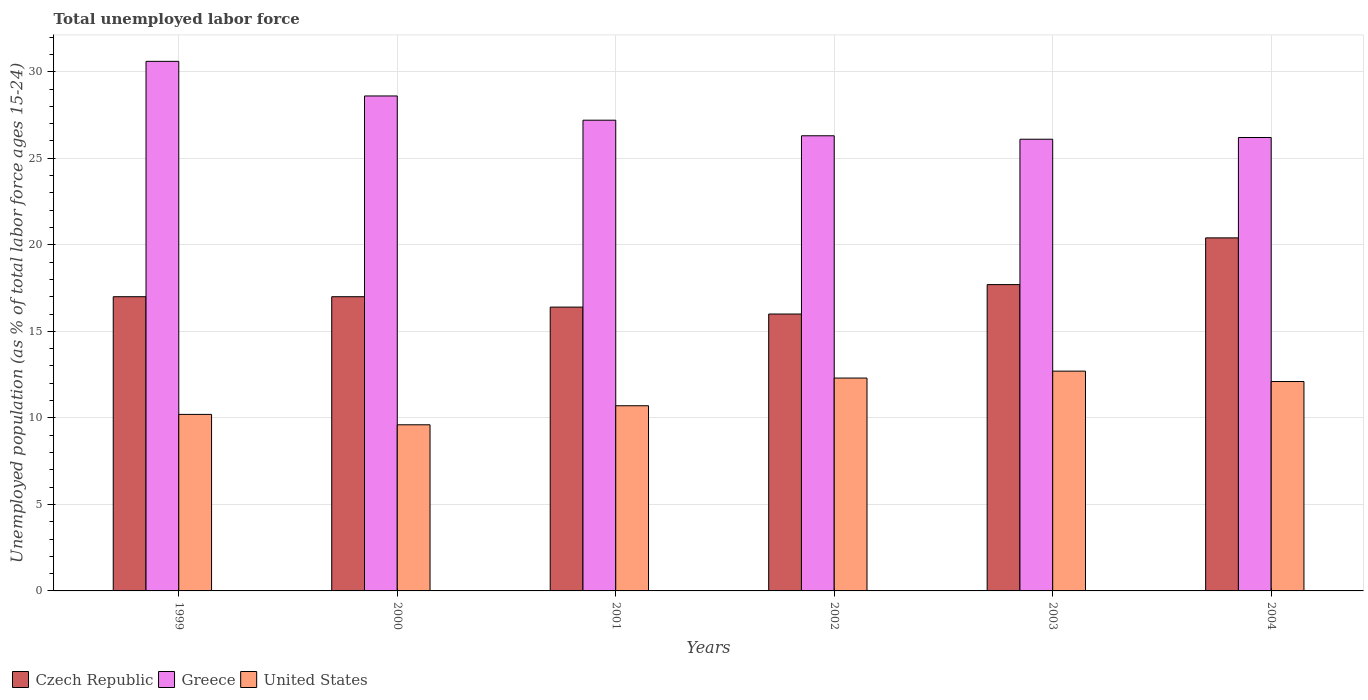How many groups of bars are there?
Your response must be concise. 6. How many bars are there on the 1st tick from the right?
Offer a very short reply. 3. What is the percentage of unemployed population in in United States in 2001?
Offer a very short reply. 10.7. Across all years, what is the maximum percentage of unemployed population in in United States?
Ensure brevity in your answer.  12.7. Across all years, what is the minimum percentage of unemployed population in in United States?
Offer a very short reply. 9.6. What is the total percentage of unemployed population in in Greece in the graph?
Provide a short and direct response. 165. What is the difference between the percentage of unemployed population in in Czech Republic in 2002 and that in 2004?
Your answer should be very brief. -4.4. What is the difference between the percentage of unemployed population in in United States in 2000 and the percentage of unemployed population in in Czech Republic in 2001?
Offer a terse response. -6.8. What is the average percentage of unemployed population in in United States per year?
Provide a succinct answer. 11.27. In the year 2000, what is the difference between the percentage of unemployed population in in Czech Republic and percentage of unemployed population in in Greece?
Your answer should be very brief. -11.6. In how many years, is the percentage of unemployed population in in Greece greater than 25 %?
Keep it short and to the point. 6. What is the ratio of the percentage of unemployed population in in Czech Republic in 2001 to that in 2002?
Your answer should be compact. 1.02. What is the difference between the highest and the second highest percentage of unemployed population in in Czech Republic?
Provide a short and direct response. 2.7. What does the 1st bar from the left in 2000 represents?
Your answer should be very brief. Czech Republic. Is it the case that in every year, the sum of the percentage of unemployed population in in United States and percentage of unemployed population in in Czech Republic is greater than the percentage of unemployed population in in Greece?
Provide a succinct answer. No. Are all the bars in the graph horizontal?
Ensure brevity in your answer.  No. How many years are there in the graph?
Ensure brevity in your answer.  6. What is the difference between two consecutive major ticks on the Y-axis?
Offer a very short reply. 5. Does the graph contain any zero values?
Offer a terse response. No. Where does the legend appear in the graph?
Make the answer very short. Bottom left. What is the title of the graph?
Offer a terse response. Total unemployed labor force. Does "Samoa" appear as one of the legend labels in the graph?
Provide a short and direct response. No. What is the label or title of the Y-axis?
Your answer should be compact. Unemployed population (as % of total labor force ages 15-24). What is the Unemployed population (as % of total labor force ages 15-24) of Greece in 1999?
Your answer should be compact. 30.6. What is the Unemployed population (as % of total labor force ages 15-24) of United States in 1999?
Ensure brevity in your answer.  10.2. What is the Unemployed population (as % of total labor force ages 15-24) in Czech Republic in 2000?
Your answer should be very brief. 17. What is the Unemployed population (as % of total labor force ages 15-24) of Greece in 2000?
Ensure brevity in your answer.  28.6. What is the Unemployed population (as % of total labor force ages 15-24) of United States in 2000?
Offer a very short reply. 9.6. What is the Unemployed population (as % of total labor force ages 15-24) of Czech Republic in 2001?
Ensure brevity in your answer.  16.4. What is the Unemployed population (as % of total labor force ages 15-24) in Greece in 2001?
Provide a short and direct response. 27.2. What is the Unemployed population (as % of total labor force ages 15-24) in United States in 2001?
Your response must be concise. 10.7. What is the Unemployed population (as % of total labor force ages 15-24) of Czech Republic in 2002?
Provide a succinct answer. 16. What is the Unemployed population (as % of total labor force ages 15-24) in Greece in 2002?
Make the answer very short. 26.3. What is the Unemployed population (as % of total labor force ages 15-24) of United States in 2002?
Provide a succinct answer. 12.3. What is the Unemployed population (as % of total labor force ages 15-24) in Czech Republic in 2003?
Your answer should be compact. 17.7. What is the Unemployed population (as % of total labor force ages 15-24) in Greece in 2003?
Your response must be concise. 26.1. What is the Unemployed population (as % of total labor force ages 15-24) of United States in 2003?
Provide a short and direct response. 12.7. What is the Unemployed population (as % of total labor force ages 15-24) in Czech Republic in 2004?
Provide a short and direct response. 20.4. What is the Unemployed population (as % of total labor force ages 15-24) of Greece in 2004?
Offer a very short reply. 26.2. What is the Unemployed population (as % of total labor force ages 15-24) of United States in 2004?
Make the answer very short. 12.1. Across all years, what is the maximum Unemployed population (as % of total labor force ages 15-24) in Czech Republic?
Keep it short and to the point. 20.4. Across all years, what is the maximum Unemployed population (as % of total labor force ages 15-24) of Greece?
Provide a succinct answer. 30.6. Across all years, what is the maximum Unemployed population (as % of total labor force ages 15-24) of United States?
Make the answer very short. 12.7. Across all years, what is the minimum Unemployed population (as % of total labor force ages 15-24) in Greece?
Give a very brief answer. 26.1. Across all years, what is the minimum Unemployed population (as % of total labor force ages 15-24) in United States?
Make the answer very short. 9.6. What is the total Unemployed population (as % of total labor force ages 15-24) of Czech Republic in the graph?
Provide a short and direct response. 104.5. What is the total Unemployed population (as % of total labor force ages 15-24) of Greece in the graph?
Ensure brevity in your answer.  165. What is the total Unemployed population (as % of total labor force ages 15-24) in United States in the graph?
Your response must be concise. 67.6. What is the difference between the Unemployed population (as % of total labor force ages 15-24) in Czech Republic in 1999 and that in 2000?
Offer a terse response. 0. What is the difference between the Unemployed population (as % of total labor force ages 15-24) of Czech Republic in 1999 and that in 2001?
Your response must be concise. 0.6. What is the difference between the Unemployed population (as % of total labor force ages 15-24) in Czech Republic in 1999 and that in 2002?
Keep it short and to the point. 1. What is the difference between the Unemployed population (as % of total labor force ages 15-24) of Greece in 1999 and that in 2002?
Your answer should be compact. 4.3. What is the difference between the Unemployed population (as % of total labor force ages 15-24) of Czech Republic in 1999 and that in 2003?
Make the answer very short. -0.7. What is the difference between the Unemployed population (as % of total labor force ages 15-24) of Greece in 1999 and that in 2003?
Your answer should be very brief. 4.5. What is the difference between the Unemployed population (as % of total labor force ages 15-24) in United States in 1999 and that in 2003?
Your response must be concise. -2.5. What is the difference between the Unemployed population (as % of total labor force ages 15-24) of Czech Republic in 1999 and that in 2004?
Your response must be concise. -3.4. What is the difference between the Unemployed population (as % of total labor force ages 15-24) in Czech Republic in 2000 and that in 2001?
Your response must be concise. 0.6. What is the difference between the Unemployed population (as % of total labor force ages 15-24) in Czech Republic in 2000 and that in 2002?
Offer a very short reply. 1. What is the difference between the Unemployed population (as % of total labor force ages 15-24) in Czech Republic in 2000 and that in 2003?
Your answer should be very brief. -0.7. What is the difference between the Unemployed population (as % of total labor force ages 15-24) of Greece in 2000 and that in 2004?
Make the answer very short. 2.4. What is the difference between the Unemployed population (as % of total labor force ages 15-24) in Czech Republic in 2001 and that in 2002?
Your answer should be very brief. 0.4. What is the difference between the Unemployed population (as % of total labor force ages 15-24) of Greece in 2001 and that in 2002?
Provide a short and direct response. 0.9. What is the difference between the Unemployed population (as % of total labor force ages 15-24) in United States in 2001 and that in 2002?
Provide a short and direct response. -1.6. What is the difference between the Unemployed population (as % of total labor force ages 15-24) of Czech Republic in 2001 and that in 2003?
Give a very brief answer. -1.3. What is the difference between the Unemployed population (as % of total labor force ages 15-24) in Greece in 2001 and that in 2003?
Make the answer very short. 1.1. What is the difference between the Unemployed population (as % of total labor force ages 15-24) in United States in 2001 and that in 2003?
Keep it short and to the point. -2. What is the difference between the Unemployed population (as % of total labor force ages 15-24) in Czech Republic in 2001 and that in 2004?
Your answer should be compact. -4. What is the difference between the Unemployed population (as % of total labor force ages 15-24) in Greece in 2001 and that in 2004?
Your answer should be compact. 1. What is the difference between the Unemployed population (as % of total labor force ages 15-24) of Czech Republic in 2002 and that in 2003?
Your answer should be compact. -1.7. What is the difference between the Unemployed population (as % of total labor force ages 15-24) in Greece in 2002 and that in 2003?
Provide a short and direct response. 0.2. What is the difference between the Unemployed population (as % of total labor force ages 15-24) in Greece in 2002 and that in 2004?
Give a very brief answer. 0.1. What is the difference between the Unemployed population (as % of total labor force ages 15-24) of United States in 2002 and that in 2004?
Keep it short and to the point. 0.2. What is the difference between the Unemployed population (as % of total labor force ages 15-24) of Czech Republic in 1999 and the Unemployed population (as % of total labor force ages 15-24) of Greece in 2001?
Give a very brief answer. -10.2. What is the difference between the Unemployed population (as % of total labor force ages 15-24) in Czech Republic in 1999 and the Unemployed population (as % of total labor force ages 15-24) in United States in 2001?
Your response must be concise. 6.3. What is the difference between the Unemployed population (as % of total labor force ages 15-24) of Greece in 1999 and the Unemployed population (as % of total labor force ages 15-24) of United States in 2001?
Your response must be concise. 19.9. What is the difference between the Unemployed population (as % of total labor force ages 15-24) in Czech Republic in 1999 and the Unemployed population (as % of total labor force ages 15-24) in Greece in 2002?
Offer a very short reply. -9.3. What is the difference between the Unemployed population (as % of total labor force ages 15-24) in Czech Republic in 1999 and the Unemployed population (as % of total labor force ages 15-24) in United States in 2002?
Provide a succinct answer. 4.7. What is the difference between the Unemployed population (as % of total labor force ages 15-24) of Greece in 1999 and the Unemployed population (as % of total labor force ages 15-24) of United States in 2003?
Give a very brief answer. 17.9. What is the difference between the Unemployed population (as % of total labor force ages 15-24) in Greece in 1999 and the Unemployed population (as % of total labor force ages 15-24) in United States in 2004?
Provide a succinct answer. 18.5. What is the difference between the Unemployed population (as % of total labor force ages 15-24) in Czech Republic in 2000 and the Unemployed population (as % of total labor force ages 15-24) in Greece in 2001?
Your answer should be very brief. -10.2. What is the difference between the Unemployed population (as % of total labor force ages 15-24) in Greece in 2000 and the Unemployed population (as % of total labor force ages 15-24) in United States in 2001?
Provide a succinct answer. 17.9. What is the difference between the Unemployed population (as % of total labor force ages 15-24) of Czech Republic in 2000 and the Unemployed population (as % of total labor force ages 15-24) of Greece in 2002?
Provide a succinct answer. -9.3. What is the difference between the Unemployed population (as % of total labor force ages 15-24) of Czech Republic in 2000 and the Unemployed population (as % of total labor force ages 15-24) of United States in 2002?
Keep it short and to the point. 4.7. What is the difference between the Unemployed population (as % of total labor force ages 15-24) in Czech Republic in 2000 and the Unemployed population (as % of total labor force ages 15-24) in Greece in 2003?
Keep it short and to the point. -9.1. What is the difference between the Unemployed population (as % of total labor force ages 15-24) of Czech Republic in 2000 and the Unemployed population (as % of total labor force ages 15-24) of United States in 2003?
Your response must be concise. 4.3. What is the difference between the Unemployed population (as % of total labor force ages 15-24) in Greece in 2000 and the Unemployed population (as % of total labor force ages 15-24) in United States in 2003?
Offer a terse response. 15.9. What is the difference between the Unemployed population (as % of total labor force ages 15-24) of Czech Republic in 2000 and the Unemployed population (as % of total labor force ages 15-24) of United States in 2004?
Your response must be concise. 4.9. What is the difference between the Unemployed population (as % of total labor force ages 15-24) of Czech Republic in 2001 and the Unemployed population (as % of total labor force ages 15-24) of Greece in 2002?
Ensure brevity in your answer.  -9.9. What is the difference between the Unemployed population (as % of total labor force ages 15-24) of Czech Republic in 2001 and the Unemployed population (as % of total labor force ages 15-24) of United States in 2002?
Your answer should be very brief. 4.1. What is the difference between the Unemployed population (as % of total labor force ages 15-24) of Greece in 2001 and the Unemployed population (as % of total labor force ages 15-24) of United States in 2002?
Offer a terse response. 14.9. What is the difference between the Unemployed population (as % of total labor force ages 15-24) in Czech Republic in 2001 and the Unemployed population (as % of total labor force ages 15-24) in United States in 2003?
Give a very brief answer. 3.7. What is the difference between the Unemployed population (as % of total labor force ages 15-24) of Czech Republic in 2001 and the Unemployed population (as % of total labor force ages 15-24) of Greece in 2004?
Your answer should be very brief. -9.8. What is the difference between the Unemployed population (as % of total labor force ages 15-24) in Czech Republic in 2001 and the Unemployed population (as % of total labor force ages 15-24) in United States in 2004?
Offer a terse response. 4.3. What is the difference between the Unemployed population (as % of total labor force ages 15-24) in Czech Republic in 2002 and the Unemployed population (as % of total labor force ages 15-24) in United States in 2003?
Make the answer very short. 3.3. What is the difference between the Unemployed population (as % of total labor force ages 15-24) in Czech Republic in 2003 and the Unemployed population (as % of total labor force ages 15-24) in Greece in 2004?
Your answer should be compact. -8.5. What is the average Unemployed population (as % of total labor force ages 15-24) in Czech Republic per year?
Make the answer very short. 17.42. What is the average Unemployed population (as % of total labor force ages 15-24) in United States per year?
Your answer should be compact. 11.27. In the year 1999, what is the difference between the Unemployed population (as % of total labor force ages 15-24) in Czech Republic and Unemployed population (as % of total labor force ages 15-24) in United States?
Offer a very short reply. 6.8. In the year 1999, what is the difference between the Unemployed population (as % of total labor force ages 15-24) of Greece and Unemployed population (as % of total labor force ages 15-24) of United States?
Ensure brevity in your answer.  20.4. In the year 2002, what is the difference between the Unemployed population (as % of total labor force ages 15-24) in Greece and Unemployed population (as % of total labor force ages 15-24) in United States?
Keep it short and to the point. 14. In the year 2004, what is the difference between the Unemployed population (as % of total labor force ages 15-24) of Czech Republic and Unemployed population (as % of total labor force ages 15-24) of Greece?
Keep it short and to the point. -5.8. In the year 2004, what is the difference between the Unemployed population (as % of total labor force ages 15-24) of Czech Republic and Unemployed population (as % of total labor force ages 15-24) of United States?
Ensure brevity in your answer.  8.3. In the year 2004, what is the difference between the Unemployed population (as % of total labor force ages 15-24) of Greece and Unemployed population (as % of total labor force ages 15-24) of United States?
Your response must be concise. 14.1. What is the ratio of the Unemployed population (as % of total labor force ages 15-24) of Greece in 1999 to that in 2000?
Offer a terse response. 1.07. What is the ratio of the Unemployed population (as % of total labor force ages 15-24) in United States in 1999 to that in 2000?
Your answer should be compact. 1.06. What is the ratio of the Unemployed population (as % of total labor force ages 15-24) of Czech Republic in 1999 to that in 2001?
Your response must be concise. 1.04. What is the ratio of the Unemployed population (as % of total labor force ages 15-24) in United States in 1999 to that in 2001?
Offer a terse response. 0.95. What is the ratio of the Unemployed population (as % of total labor force ages 15-24) in Czech Republic in 1999 to that in 2002?
Offer a very short reply. 1.06. What is the ratio of the Unemployed population (as % of total labor force ages 15-24) of Greece in 1999 to that in 2002?
Provide a short and direct response. 1.16. What is the ratio of the Unemployed population (as % of total labor force ages 15-24) in United States in 1999 to that in 2002?
Your answer should be compact. 0.83. What is the ratio of the Unemployed population (as % of total labor force ages 15-24) of Czech Republic in 1999 to that in 2003?
Your answer should be very brief. 0.96. What is the ratio of the Unemployed population (as % of total labor force ages 15-24) of Greece in 1999 to that in 2003?
Give a very brief answer. 1.17. What is the ratio of the Unemployed population (as % of total labor force ages 15-24) in United States in 1999 to that in 2003?
Your answer should be very brief. 0.8. What is the ratio of the Unemployed population (as % of total labor force ages 15-24) in Greece in 1999 to that in 2004?
Your answer should be compact. 1.17. What is the ratio of the Unemployed population (as % of total labor force ages 15-24) in United States in 1999 to that in 2004?
Your response must be concise. 0.84. What is the ratio of the Unemployed population (as % of total labor force ages 15-24) of Czech Republic in 2000 to that in 2001?
Your answer should be compact. 1.04. What is the ratio of the Unemployed population (as % of total labor force ages 15-24) in Greece in 2000 to that in 2001?
Your answer should be compact. 1.05. What is the ratio of the Unemployed population (as % of total labor force ages 15-24) in United States in 2000 to that in 2001?
Ensure brevity in your answer.  0.9. What is the ratio of the Unemployed population (as % of total labor force ages 15-24) of Greece in 2000 to that in 2002?
Your answer should be compact. 1.09. What is the ratio of the Unemployed population (as % of total labor force ages 15-24) of United States in 2000 to that in 2002?
Offer a terse response. 0.78. What is the ratio of the Unemployed population (as % of total labor force ages 15-24) in Czech Republic in 2000 to that in 2003?
Give a very brief answer. 0.96. What is the ratio of the Unemployed population (as % of total labor force ages 15-24) of Greece in 2000 to that in 2003?
Offer a terse response. 1.1. What is the ratio of the Unemployed population (as % of total labor force ages 15-24) of United States in 2000 to that in 2003?
Provide a short and direct response. 0.76. What is the ratio of the Unemployed population (as % of total labor force ages 15-24) in Greece in 2000 to that in 2004?
Give a very brief answer. 1.09. What is the ratio of the Unemployed population (as % of total labor force ages 15-24) of United States in 2000 to that in 2004?
Your answer should be very brief. 0.79. What is the ratio of the Unemployed population (as % of total labor force ages 15-24) in Czech Republic in 2001 to that in 2002?
Offer a very short reply. 1.02. What is the ratio of the Unemployed population (as % of total labor force ages 15-24) of Greece in 2001 to that in 2002?
Keep it short and to the point. 1.03. What is the ratio of the Unemployed population (as % of total labor force ages 15-24) in United States in 2001 to that in 2002?
Provide a succinct answer. 0.87. What is the ratio of the Unemployed population (as % of total labor force ages 15-24) in Czech Republic in 2001 to that in 2003?
Your answer should be compact. 0.93. What is the ratio of the Unemployed population (as % of total labor force ages 15-24) in Greece in 2001 to that in 2003?
Ensure brevity in your answer.  1.04. What is the ratio of the Unemployed population (as % of total labor force ages 15-24) in United States in 2001 to that in 2003?
Your answer should be very brief. 0.84. What is the ratio of the Unemployed population (as % of total labor force ages 15-24) in Czech Republic in 2001 to that in 2004?
Make the answer very short. 0.8. What is the ratio of the Unemployed population (as % of total labor force ages 15-24) in Greece in 2001 to that in 2004?
Give a very brief answer. 1.04. What is the ratio of the Unemployed population (as % of total labor force ages 15-24) of United States in 2001 to that in 2004?
Your answer should be very brief. 0.88. What is the ratio of the Unemployed population (as % of total labor force ages 15-24) of Czech Republic in 2002 to that in 2003?
Your response must be concise. 0.9. What is the ratio of the Unemployed population (as % of total labor force ages 15-24) in Greece in 2002 to that in 2003?
Provide a succinct answer. 1.01. What is the ratio of the Unemployed population (as % of total labor force ages 15-24) in United States in 2002 to that in 2003?
Ensure brevity in your answer.  0.97. What is the ratio of the Unemployed population (as % of total labor force ages 15-24) of Czech Republic in 2002 to that in 2004?
Your response must be concise. 0.78. What is the ratio of the Unemployed population (as % of total labor force ages 15-24) of United States in 2002 to that in 2004?
Offer a terse response. 1.02. What is the ratio of the Unemployed population (as % of total labor force ages 15-24) of Czech Republic in 2003 to that in 2004?
Ensure brevity in your answer.  0.87. What is the ratio of the Unemployed population (as % of total labor force ages 15-24) in Greece in 2003 to that in 2004?
Your answer should be very brief. 1. What is the ratio of the Unemployed population (as % of total labor force ages 15-24) in United States in 2003 to that in 2004?
Your answer should be very brief. 1.05. What is the difference between the highest and the second highest Unemployed population (as % of total labor force ages 15-24) of United States?
Provide a succinct answer. 0.4. What is the difference between the highest and the lowest Unemployed population (as % of total labor force ages 15-24) of Czech Republic?
Your response must be concise. 4.4. What is the difference between the highest and the lowest Unemployed population (as % of total labor force ages 15-24) of United States?
Your answer should be very brief. 3.1. 